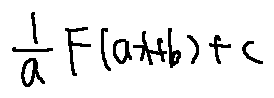Convert formula to latex. <formula><loc_0><loc_0><loc_500><loc_500>\frac { 1 } { a } F ( a x + b ) + C</formula> 